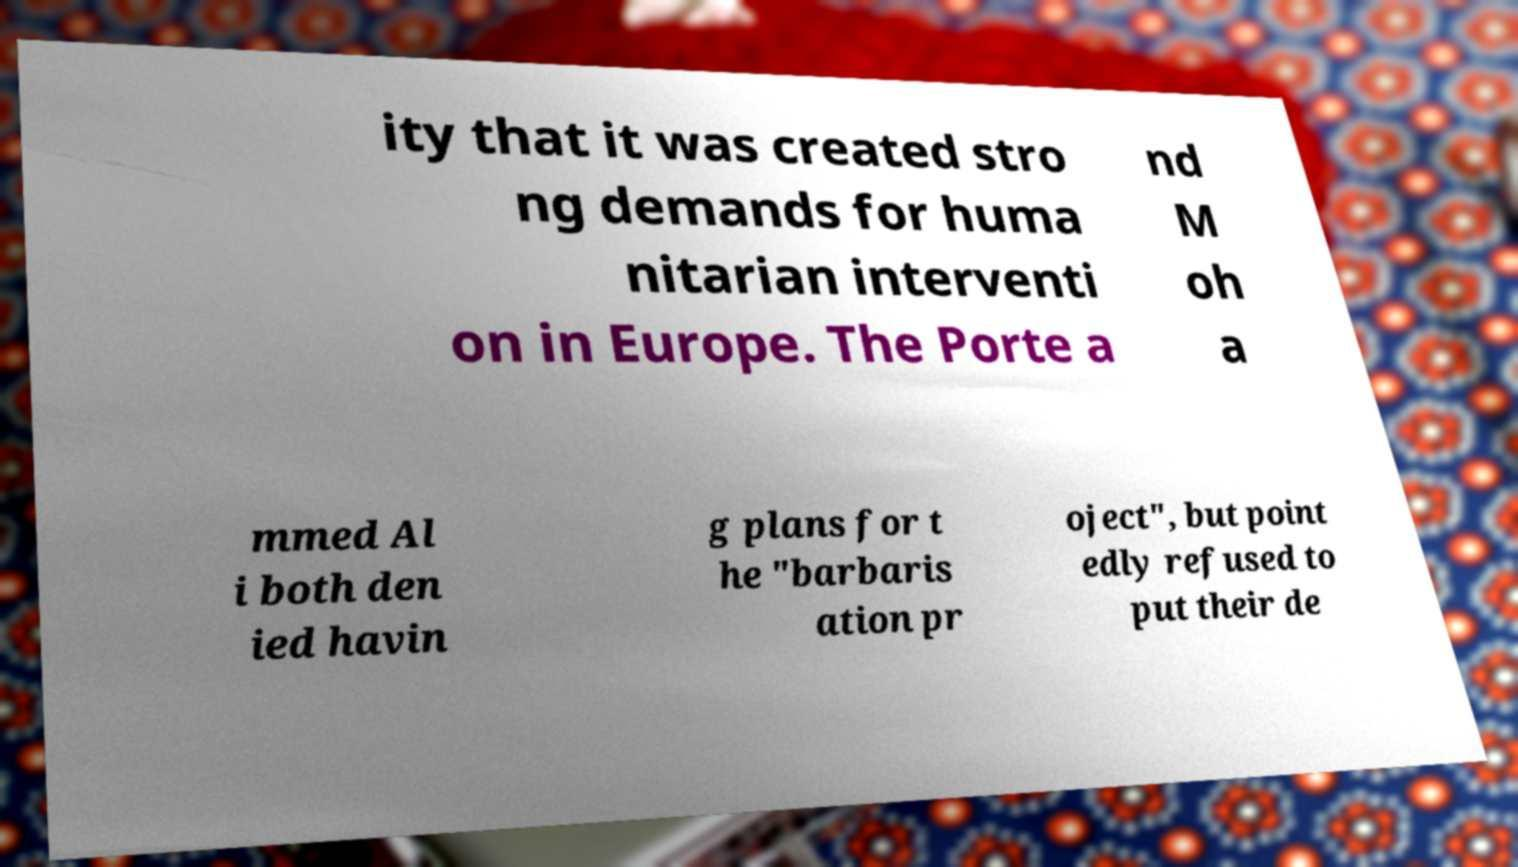Can you read and provide the text displayed in the image?This photo seems to have some interesting text. Can you extract and type it out for me? ity that it was created stro ng demands for huma nitarian interventi on in Europe. The Porte a nd M oh a mmed Al i both den ied havin g plans for t he "barbaris ation pr oject", but point edly refused to put their de 